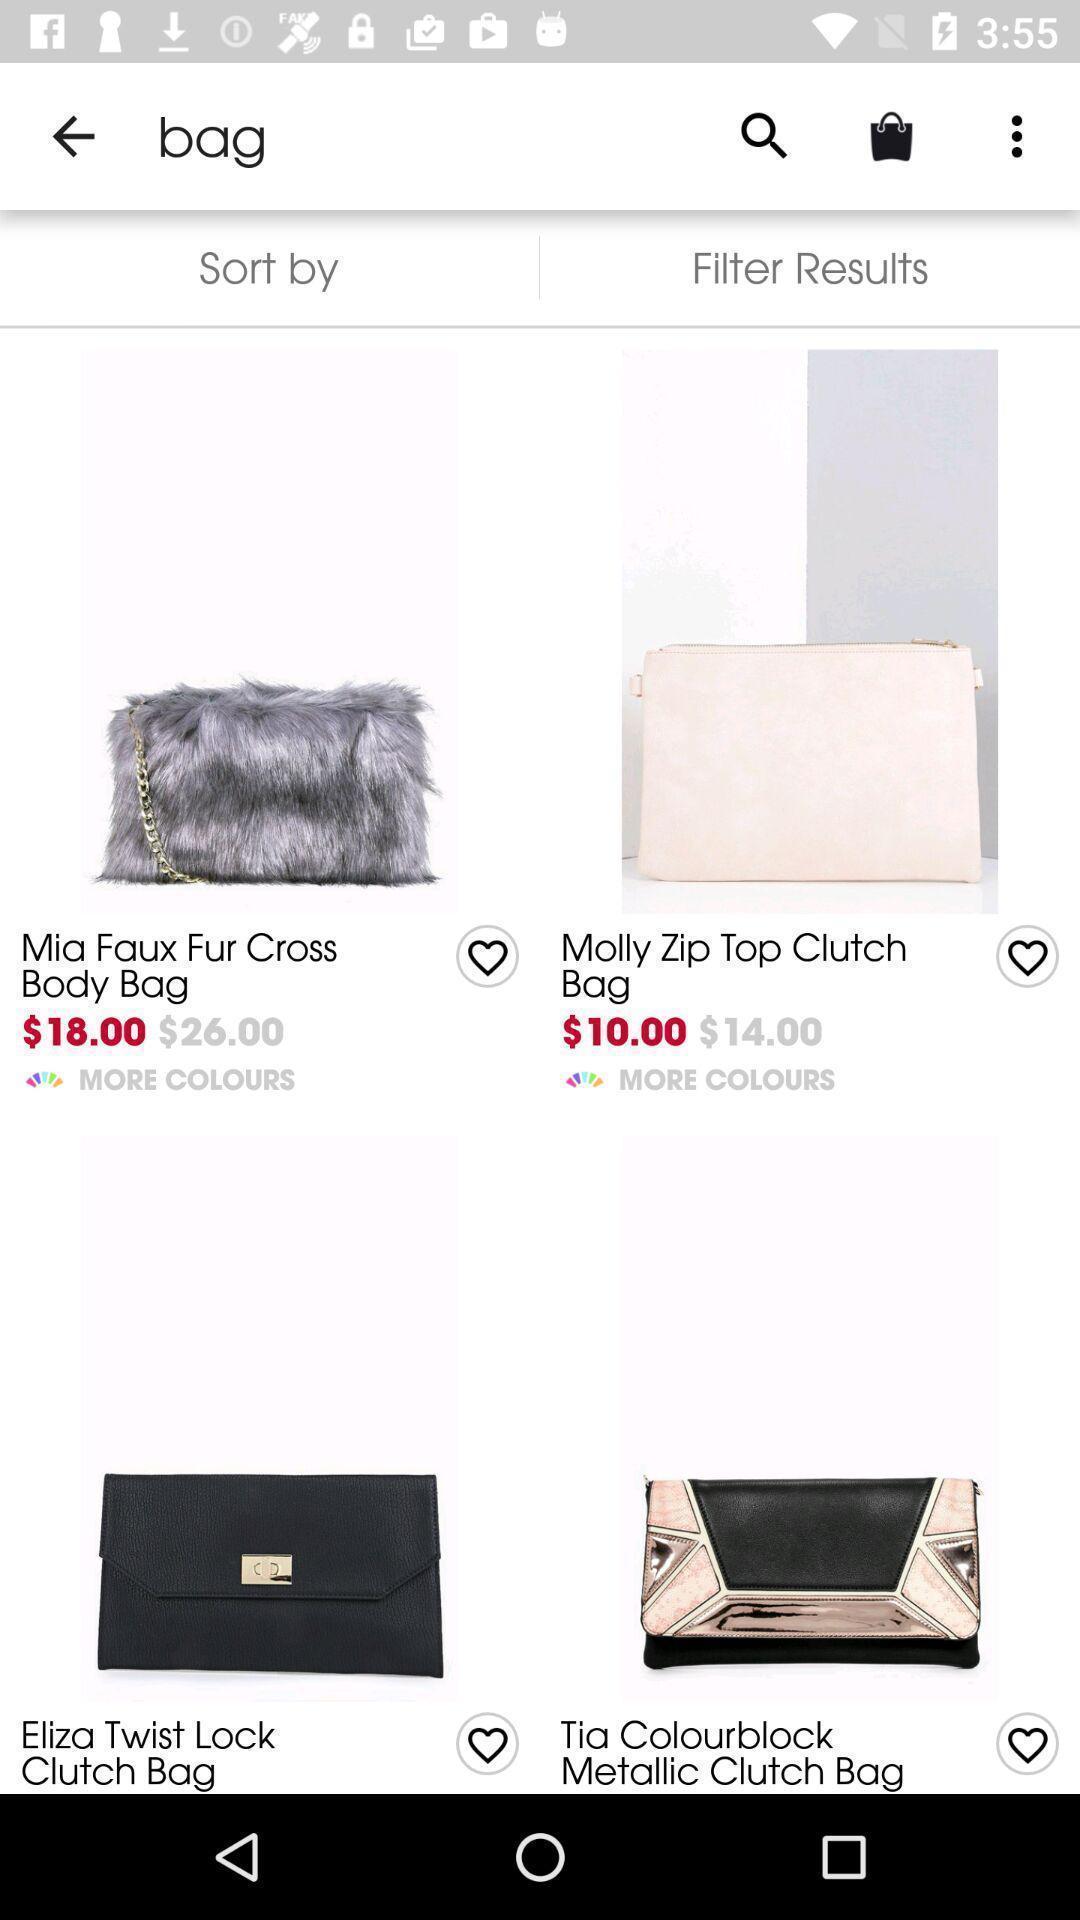What details can you identify in this image? Screen showing page of an shopping application. 